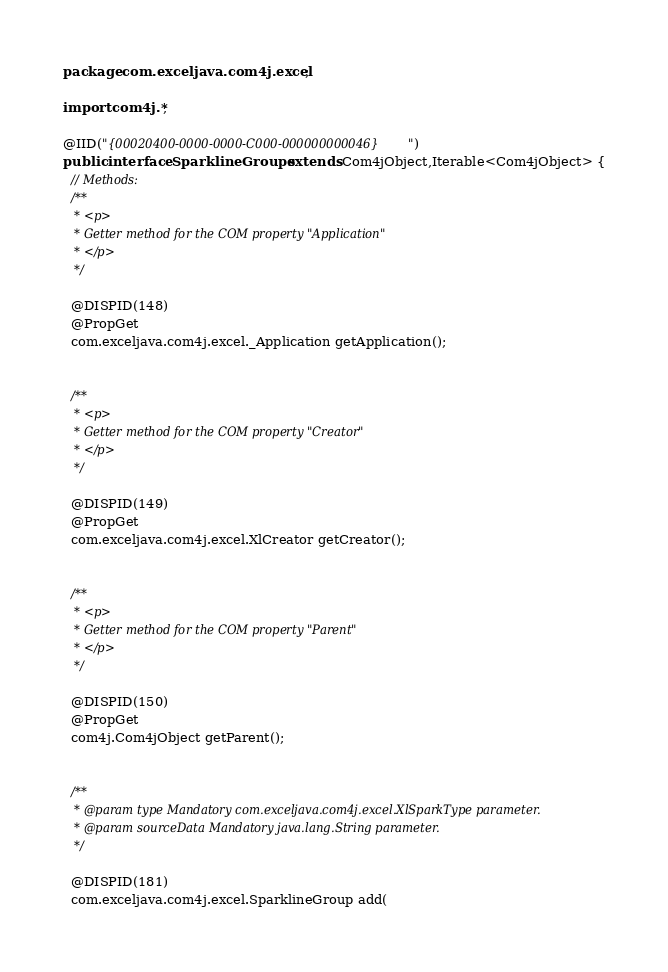<code> <loc_0><loc_0><loc_500><loc_500><_Java_>package com.exceljava.com4j.excel  ;

import com4j.*;

@IID("{00020400-0000-0000-C000-000000000046}")
public interface SparklineGroups extends Com4jObject,Iterable<Com4jObject> {
  // Methods:
  /**
   * <p>
   * Getter method for the COM property "Application"
   * </p>
   */

  @DISPID(148)
  @PropGet
  com.exceljava.com4j.excel._Application getApplication();


  /**
   * <p>
   * Getter method for the COM property "Creator"
   * </p>
   */

  @DISPID(149)
  @PropGet
  com.exceljava.com4j.excel.XlCreator getCreator();


  /**
   * <p>
   * Getter method for the COM property "Parent"
   * </p>
   */

  @DISPID(150)
  @PropGet
  com4j.Com4jObject getParent();


  /**
   * @param type Mandatory com.exceljava.com4j.excel.XlSparkType parameter.
   * @param sourceData Mandatory java.lang.String parameter.
   */

  @DISPID(181)
  com.exceljava.com4j.excel.SparklineGroup add(</code> 